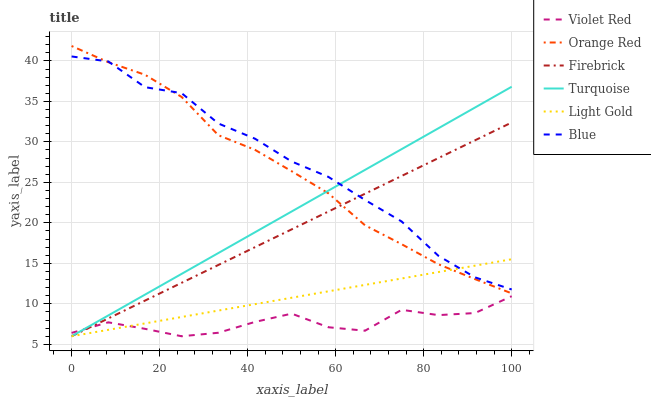Does Violet Red have the minimum area under the curve?
Answer yes or no. Yes. Does Blue have the maximum area under the curve?
Answer yes or no. Yes. Does Firebrick have the minimum area under the curve?
Answer yes or no. No. Does Firebrick have the maximum area under the curve?
Answer yes or no. No. Is Light Gold the smoothest?
Answer yes or no. Yes. Is Violet Red the roughest?
Answer yes or no. Yes. Is Firebrick the smoothest?
Answer yes or no. No. Is Firebrick the roughest?
Answer yes or no. No. Does Orange Red have the lowest value?
Answer yes or no. No. Does Orange Red have the highest value?
Answer yes or no. Yes. Does Firebrick have the highest value?
Answer yes or no. No. Is Violet Red less than Blue?
Answer yes or no. Yes. Is Blue greater than Violet Red?
Answer yes or no. Yes. Does Turquoise intersect Orange Red?
Answer yes or no. Yes. Is Turquoise less than Orange Red?
Answer yes or no. No. Is Turquoise greater than Orange Red?
Answer yes or no. No. Does Violet Red intersect Blue?
Answer yes or no. No. 